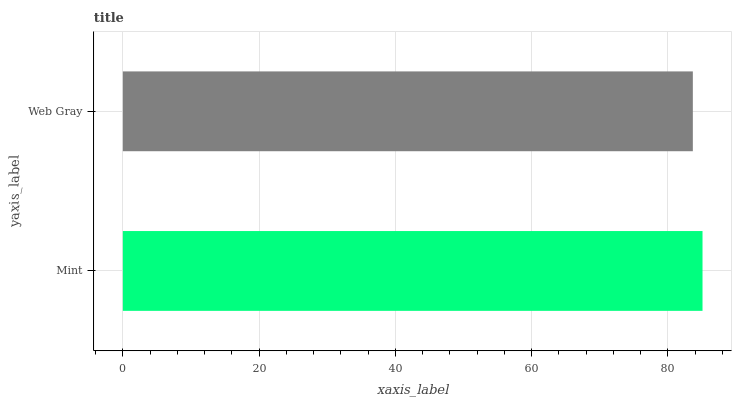Is Web Gray the minimum?
Answer yes or no. Yes. Is Mint the maximum?
Answer yes or no. Yes. Is Web Gray the maximum?
Answer yes or no. No. Is Mint greater than Web Gray?
Answer yes or no. Yes. Is Web Gray less than Mint?
Answer yes or no. Yes. Is Web Gray greater than Mint?
Answer yes or no. No. Is Mint less than Web Gray?
Answer yes or no. No. Is Mint the high median?
Answer yes or no. Yes. Is Web Gray the low median?
Answer yes or no. Yes. Is Web Gray the high median?
Answer yes or no. No. Is Mint the low median?
Answer yes or no. No. 